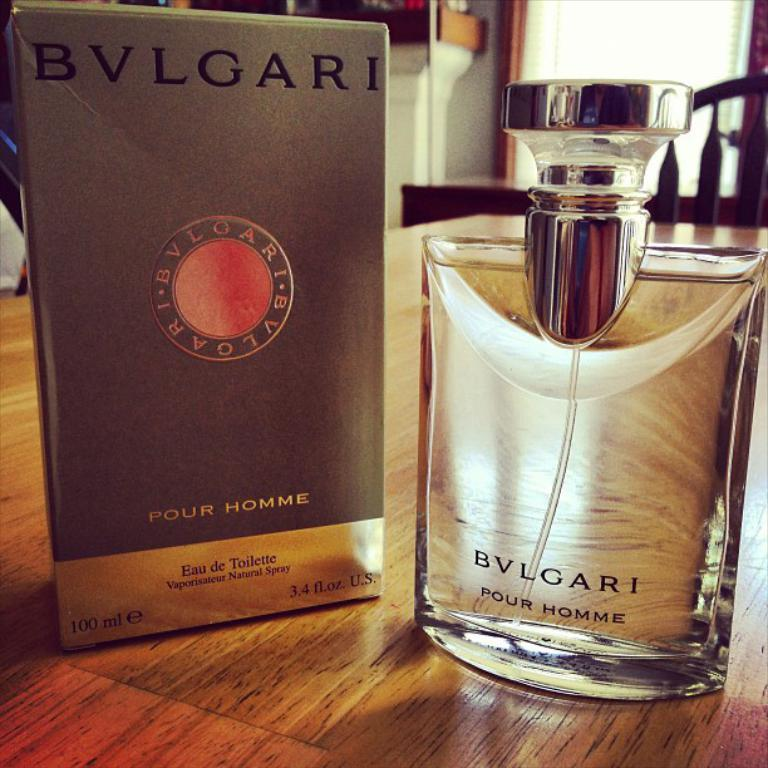<image>
Create a compact narrative representing the image presented. A bottle of BVLGARI cologne for men stands next to it's package on a wood table. 